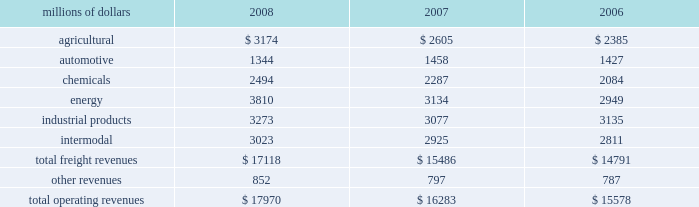Notes to the consolidated financial statements union pacific corporation and subsidiary companies for purposes of this report , unless the context otherwise requires , all references herein to the 201ccorporation 201d , 201cupc 201d , 201cwe 201d , 201cus 201d , and 201cour 201d mean union pacific corporation and its subsidiaries , including union pacific railroad company , which will be separately referred to herein as 201cuprr 201d or the 201crailroad 201d .
Nature of operations and significant accounting policies operations and segmentation 2013 we are a class i railroad that operates in the united states .
We have 32012 route miles , linking pacific coast and gulf coast ports with the midwest and eastern united states gateways and providing several corridors to key mexican gateways .
We serve the western two- thirds of the country and maintain coordinated schedules with other rail carriers for the handling of freight to and from the atlantic coast , the pacific coast , the southeast , the southwest , canada , and mexico .
Export and import traffic is moved through gulf coast and pacific coast ports and across the mexican and canadian borders .
The railroad , along with its subsidiaries and rail affiliates , is our one reportable operating segment .
Although revenues are analyzed by commodity group , we analyze the net financial results of the railroad as one segment due to the integrated nature of our rail network .
The table provides revenue by commodity group : millions of dollars 2008 2007 2006 .
Basis of presentation 2013 certain prior year amounts have been reclassified to conform to the current period financial statement presentation .
The reclassifications include reporting freight revenues instead of commodity revenues .
The amounts reclassified from freight revenues to other revenues totaled $ 30 million and $ 71 million for the years ended december 31 , 2007 , and december 31 , 2006 , respectively .
In addition , we modified our operating expense categories to report fuel used in railroad operations as a stand-alone category , to combine purchased services and materials into one line , and to reclassify certain other expenses among operating expense categories .
These reclassifications had no impact on previously reported operating revenues , total operating expenses , operating income or net income .
Significant accounting policies principles of consolidation 2013 the consolidated financial statements include the accounts of union pacific corporation and all of its subsidiaries .
Investments in affiliated companies ( 20% ( 20 % ) to 50% ( 50 % ) owned ) are accounted for using the equity method of accounting .
All significant intercompany transactions are eliminated .
The corporation evaluates its less than majority-owned investments for consolidation .
What percentage of total freight revenues were energy in 2008? 
Computations: (3810 / 17118)
Answer: 0.22257. 